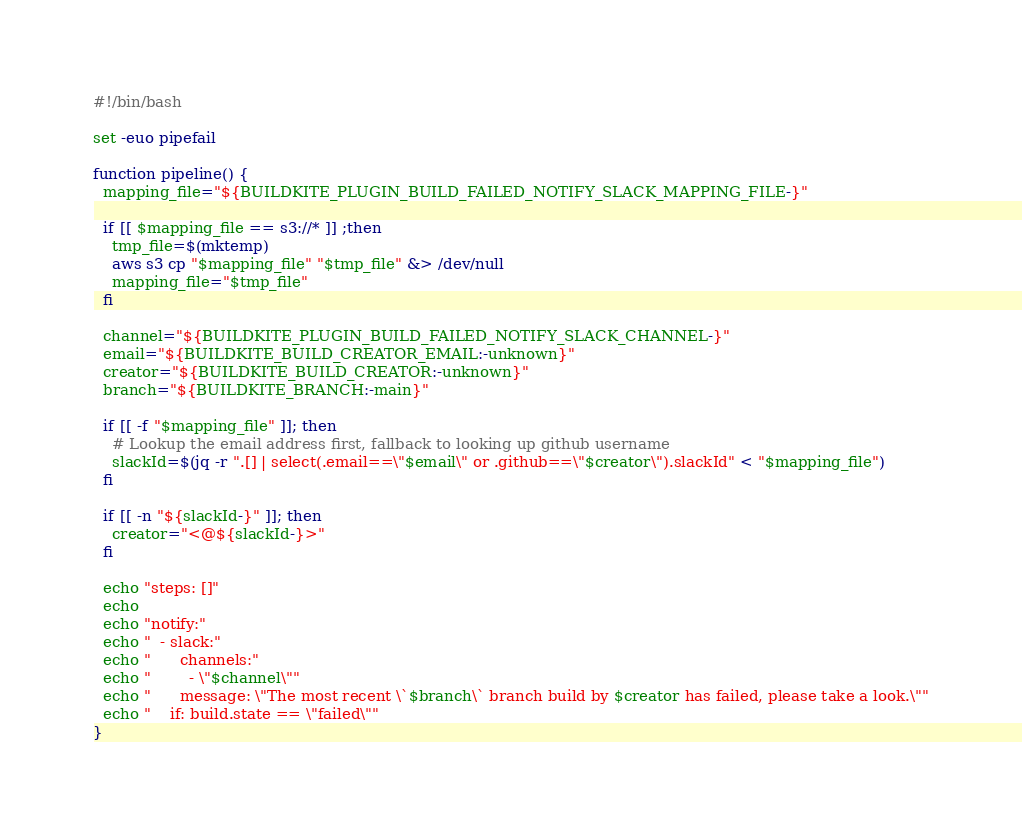Convert code to text. <code><loc_0><loc_0><loc_500><loc_500><_Bash_>#!/bin/bash

set -euo pipefail

function pipeline() {
  mapping_file="${BUILDKITE_PLUGIN_BUILD_FAILED_NOTIFY_SLACK_MAPPING_FILE-}"

  if [[ $mapping_file == s3://* ]] ;then
    tmp_file=$(mktemp)
    aws s3 cp "$mapping_file" "$tmp_file" &> /dev/null
    mapping_file="$tmp_file"
  fi

  channel="${BUILDKITE_PLUGIN_BUILD_FAILED_NOTIFY_SLACK_CHANNEL-}"
  email="${BUILDKITE_BUILD_CREATOR_EMAIL:-unknown}"
  creator="${BUILDKITE_BUILD_CREATOR:-unknown}"
  branch="${BUILDKITE_BRANCH:-main}"

  if [[ -f "$mapping_file" ]]; then
    # Lookup the email address first, fallback to looking up github username
    slackId=$(jq -r ".[] | select(.email==\"$email\" or .github==\"$creator\").slackId" < "$mapping_file")
  fi

  if [[ -n "${slackId-}" ]]; then
    creator="<@${slackId-}>"
  fi

  echo "steps: []"
  echo
  echo "notify:"
  echo "  - slack:"
  echo "      channels:"
  echo "        - \"$channel\""
  echo "      message: \"The most recent \`$branch\` branch build by $creator has failed, please take a look.\""
  echo "    if: build.state == \"failed\""
}</code> 